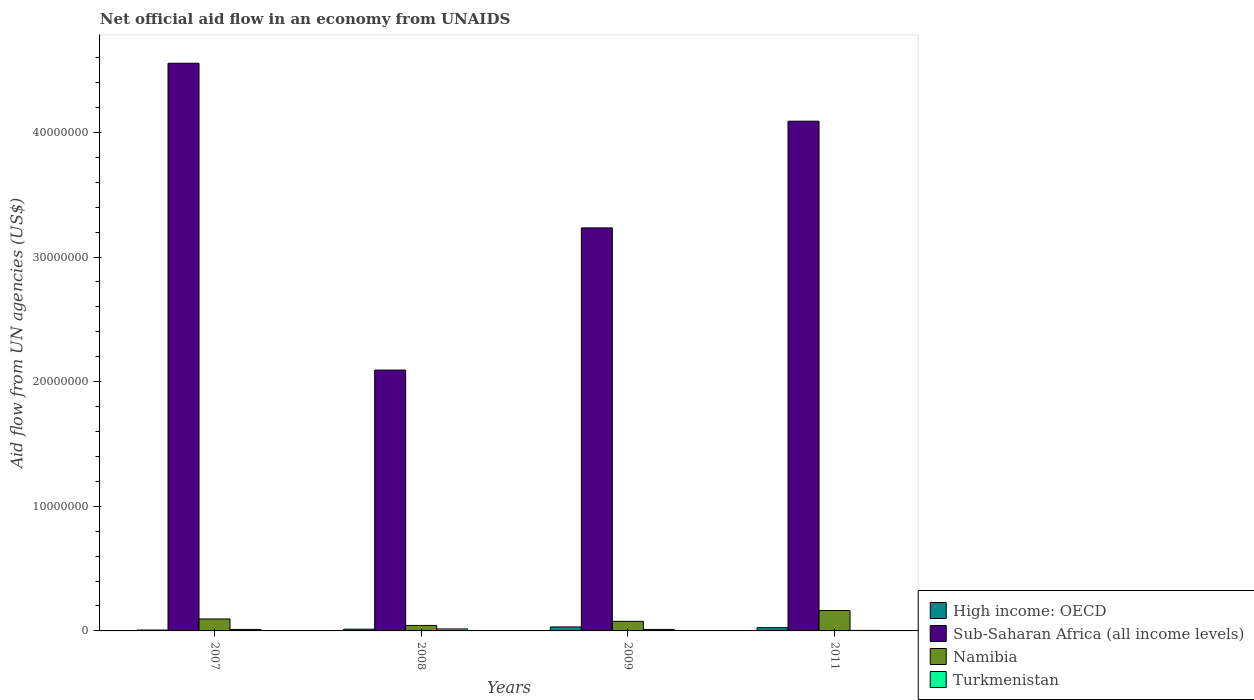How many bars are there on the 1st tick from the left?
Ensure brevity in your answer.  4. What is the label of the 4th group of bars from the left?
Offer a terse response. 2011. In how many cases, is the number of bars for a given year not equal to the number of legend labels?
Provide a short and direct response. 0. What is the net official aid flow in High income: OECD in 2011?
Your answer should be very brief. 2.60e+05. Across all years, what is the minimum net official aid flow in High income: OECD?
Provide a succinct answer. 7.00e+04. What is the total net official aid flow in High income: OECD in the graph?
Your answer should be compact. 7.90e+05. What is the difference between the net official aid flow in High income: OECD in 2007 and that in 2008?
Offer a terse response. -7.00e+04. What is the difference between the net official aid flow in Turkmenistan in 2011 and the net official aid flow in Namibia in 2007?
Your answer should be compact. -9.20e+05. What is the average net official aid flow in Sub-Saharan Africa (all income levels) per year?
Your answer should be very brief. 3.49e+07. In how many years, is the net official aid flow in Sub-Saharan Africa (all income levels) greater than 14000000 US$?
Provide a succinct answer. 4. What is the ratio of the net official aid flow in Sub-Saharan Africa (all income levels) in 2008 to that in 2011?
Offer a terse response. 0.51. Is the net official aid flow in Sub-Saharan Africa (all income levels) in 2007 less than that in 2008?
Keep it short and to the point. No. What is the difference between the highest and the second highest net official aid flow in Namibia?
Give a very brief answer. 6.80e+05. What is the difference between the highest and the lowest net official aid flow in High income: OECD?
Give a very brief answer. 2.50e+05. Is the sum of the net official aid flow in Sub-Saharan Africa (all income levels) in 2007 and 2009 greater than the maximum net official aid flow in High income: OECD across all years?
Provide a short and direct response. Yes. Is it the case that in every year, the sum of the net official aid flow in Namibia and net official aid flow in Turkmenistan is greater than the sum of net official aid flow in Sub-Saharan Africa (all income levels) and net official aid flow in High income: OECD?
Keep it short and to the point. Yes. What does the 4th bar from the left in 2009 represents?
Keep it short and to the point. Turkmenistan. What does the 3rd bar from the right in 2011 represents?
Give a very brief answer. Sub-Saharan Africa (all income levels). Is it the case that in every year, the sum of the net official aid flow in Turkmenistan and net official aid flow in High income: OECD is greater than the net official aid flow in Sub-Saharan Africa (all income levels)?
Offer a terse response. No. How many bars are there?
Your response must be concise. 16. Are all the bars in the graph horizontal?
Provide a short and direct response. No. Are the values on the major ticks of Y-axis written in scientific E-notation?
Your response must be concise. No. Does the graph contain any zero values?
Keep it short and to the point. No. Does the graph contain grids?
Ensure brevity in your answer.  No. Where does the legend appear in the graph?
Provide a short and direct response. Bottom right. How many legend labels are there?
Your answer should be very brief. 4. What is the title of the graph?
Offer a terse response. Net official aid flow in an economy from UNAIDS. What is the label or title of the Y-axis?
Provide a succinct answer. Aid flow from UN agencies (US$). What is the Aid flow from UN agencies (US$) of Sub-Saharan Africa (all income levels) in 2007?
Your answer should be compact. 4.56e+07. What is the Aid flow from UN agencies (US$) in Namibia in 2007?
Your response must be concise. 9.60e+05. What is the Aid flow from UN agencies (US$) of Sub-Saharan Africa (all income levels) in 2008?
Your answer should be compact. 2.09e+07. What is the Aid flow from UN agencies (US$) in Namibia in 2008?
Offer a very short reply. 4.40e+05. What is the Aid flow from UN agencies (US$) of High income: OECD in 2009?
Your response must be concise. 3.20e+05. What is the Aid flow from UN agencies (US$) in Sub-Saharan Africa (all income levels) in 2009?
Give a very brief answer. 3.23e+07. What is the Aid flow from UN agencies (US$) in Namibia in 2009?
Offer a very short reply. 7.70e+05. What is the Aid flow from UN agencies (US$) of High income: OECD in 2011?
Provide a short and direct response. 2.60e+05. What is the Aid flow from UN agencies (US$) of Sub-Saharan Africa (all income levels) in 2011?
Give a very brief answer. 4.09e+07. What is the Aid flow from UN agencies (US$) in Namibia in 2011?
Keep it short and to the point. 1.64e+06. Across all years, what is the maximum Aid flow from UN agencies (US$) of Sub-Saharan Africa (all income levels)?
Give a very brief answer. 4.56e+07. Across all years, what is the maximum Aid flow from UN agencies (US$) in Namibia?
Provide a short and direct response. 1.64e+06. Across all years, what is the maximum Aid flow from UN agencies (US$) of Turkmenistan?
Give a very brief answer. 1.60e+05. Across all years, what is the minimum Aid flow from UN agencies (US$) in High income: OECD?
Provide a short and direct response. 7.00e+04. Across all years, what is the minimum Aid flow from UN agencies (US$) in Sub-Saharan Africa (all income levels)?
Your response must be concise. 2.09e+07. Across all years, what is the minimum Aid flow from UN agencies (US$) in Turkmenistan?
Provide a short and direct response. 4.00e+04. What is the total Aid flow from UN agencies (US$) of High income: OECD in the graph?
Offer a very short reply. 7.90e+05. What is the total Aid flow from UN agencies (US$) of Sub-Saharan Africa (all income levels) in the graph?
Keep it short and to the point. 1.40e+08. What is the total Aid flow from UN agencies (US$) in Namibia in the graph?
Give a very brief answer. 3.81e+06. What is the difference between the Aid flow from UN agencies (US$) of Sub-Saharan Africa (all income levels) in 2007 and that in 2008?
Make the answer very short. 2.46e+07. What is the difference between the Aid flow from UN agencies (US$) of Namibia in 2007 and that in 2008?
Your response must be concise. 5.20e+05. What is the difference between the Aid flow from UN agencies (US$) of Sub-Saharan Africa (all income levels) in 2007 and that in 2009?
Your answer should be very brief. 1.32e+07. What is the difference between the Aid flow from UN agencies (US$) of High income: OECD in 2007 and that in 2011?
Give a very brief answer. -1.90e+05. What is the difference between the Aid flow from UN agencies (US$) in Sub-Saharan Africa (all income levels) in 2007 and that in 2011?
Provide a succinct answer. 4.65e+06. What is the difference between the Aid flow from UN agencies (US$) in Namibia in 2007 and that in 2011?
Give a very brief answer. -6.80e+05. What is the difference between the Aid flow from UN agencies (US$) in Turkmenistan in 2007 and that in 2011?
Give a very brief answer. 8.00e+04. What is the difference between the Aid flow from UN agencies (US$) in High income: OECD in 2008 and that in 2009?
Provide a short and direct response. -1.80e+05. What is the difference between the Aid flow from UN agencies (US$) in Sub-Saharan Africa (all income levels) in 2008 and that in 2009?
Make the answer very short. -1.14e+07. What is the difference between the Aid flow from UN agencies (US$) in Namibia in 2008 and that in 2009?
Your answer should be compact. -3.30e+05. What is the difference between the Aid flow from UN agencies (US$) in Sub-Saharan Africa (all income levels) in 2008 and that in 2011?
Offer a terse response. -2.00e+07. What is the difference between the Aid flow from UN agencies (US$) of Namibia in 2008 and that in 2011?
Keep it short and to the point. -1.20e+06. What is the difference between the Aid flow from UN agencies (US$) of High income: OECD in 2009 and that in 2011?
Your answer should be compact. 6.00e+04. What is the difference between the Aid flow from UN agencies (US$) of Sub-Saharan Africa (all income levels) in 2009 and that in 2011?
Make the answer very short. -8.56e+06. What is the difference between the Aid flow from UN agencies (US$) of Namibia in 2009 and that in 2011?
Your answer should be compact. -8.70e+05. What is the difference between the Aid flow from UN agencies (US$) of High income: OECD in 2007 and the Aid flow from UN agencies (US$) of Sub-Saharan Africa (all income levels) in 2008?
Provide a succinct answer. -2.09e+07. What is the difference between the Aid flow from UN agencies (US$) in High income: OECD in 2007 and the Aid flow from UN agencies (US$) in Namibia in 2008?
Offer a very short reply. -3.70e+05. What is the difference between the Aid flow from UN agencies (US$) of Sub-Saharan Africa (all income levels) in 2007 and the Aid flow from UN agencies (US$) of Namibia in 2008?
Ensure brevity in your answer.  4.51e+07. What is the difference between the Aid flow from UN agencies (US$) in Sub-Saharan Africa (all income levels) in 2007 and the Aid flow from UN agencies (US$) in Turkmenistan in 2008?
Offer a very short reply. 4.54e+07. What is the difference between the Aid flow from UN agencies (US$) of Namibia in 2007 and the Aid flow from UN agencies (US$) of Turkmenistan in 2008?
Your answer should be compact. 8.00e+05. What is the difference between the Aid flow from UN agencies (US$) in High income: OECD in 2007 and the Aid flow from UN agencies (US$) in Sub-Saharan Africa (all income levels) in 2009?
Offer a terse response. -3.23e+07. What is the difference between the Aid flow from UN agencies (US$) of High income: OECD in 2007 and the Aid flow from UN agencies (US$) of Namibia in 2009?
Provide a succinct answer. -7.00e+05. What is the difference between the Aid flow from UN agencies (US$) of High income: OECD in 2007 and the Aid flow from UN agencies (US$) of Turkmenistan in 2009?
Your response must be concise. -5.00e+04. What is the difference between the Aid flow from UN agencies (US$) of Sub-Saharan Africa (all income levels) in 2007 and the Aid flow from UN agencies (US$) of Namibia in 2009?
Your answer should be compact. 4.48e+07. What is the difference between the Aid flow from UN agencies (US$) in Sub-Saharan Africa (all income levels) in 2007 and the Aid flow from UN agencies (US$) in Turkmenistan in 2009?
Offer a very short reply. 4.54e+07. What is the difference between the Aid flow from UN agencies (US$) of Namibia in 2007 and the Aid flow from UN agencies (US$) of Turkmenistan in 2009?
Keep it short and to the point. 8.40e+05. What is the difference between the Aid flow from UN agencies (US$) of High income: OECD in 2007 and the Aid flow from UN agencies (US$) of Sub-Saharan Africa (all income levels) in 2011?
Keep it short and to the point. -4.08e+07. What is the difference between the Aid flow from UN agencies (US$) of High income: OECD in 2007 and the Aid flow from UN agencies (US$) of Namibia in 2011?
Ensure brevity in your answer.  -1.57e+06. What is the difference between the Aid flow from UN agencies (US$) of High income: OECD in 2007 and the Aid flow from UN agencies (US$) of Turkmenistan in 2011?
Offer a terse response. 3.00e+04. What is the difference between the Aid flow from UN agencies (US$) of Sub-Saharan Africa (all income levels) in 2007 and the Aid flow from UN agencies (US$) of Namibia in 2011?
Provide a succinct answer. 4.39e+07. What is the difference between the Aid flow from UN agencies (US$) in Sub-Saharan Africa (all income levels) in 2007 and the Aid flow from UN agencies (US$) in Turkmenistan in 2011?
Give a very brief answer. 4.55e+07. What is the difference between the Aid flow from UN agencies (US$) in Namibia in 2007 and the Aid flow from UN agencies (US$) in Turkmenistan in 2011?
Provide a succinct answer. 9.20e+05. What is the difference between the Aid flow from UN agencies (US$) of High income: OECD in 2008 and the Aid flow from UN agencies (US$) of Sub-Saharan Africa (all income levels) in 2009?
Offer a terse response. -3.22e+07. What is the difference between the Aid flow from UN agencies (US$) of High income: OECD in 2008 and the Aid flow from UN agencies (US$) of Namibia in 2009?
Your response must be concise. -6.30e+05. What is the difference between the Aid flow from UN agencies (US$) of High income: OECD in 2008 and the Aid flow from UN agencies (US$) of Turkmenistan in 2009?
Provide a succinct answer. 2.00e+04. What is the difference between the Aid flow from UN agencies (US$) in Sub-Saharan Africa (all income levels) in 2008 and the Aid flow from UN agencies (US$) in Namibia in 2009?
Ensure brevity in your answer.  2.02e+07. What is the difference between the Aid flow from UN agencies (US$) of Sub-Saharan Africa (all income levels) in 2008 and the Aid flow from UN agencies (US$) of Turkmenistan in 2009?
Provide a short and direct response. 2.08e+07. What is the difference between the Aid flow from UN agencies (US$) of Namibia in 2008 and the Aid flow from UN agencies (US$) of Turkmenistan in 2009?
Give a very brief answer. 3.20e+05. What is the difference between the Aid flow from UN agencies (US$) of High income: OECD in 2008 and the Aid flow from UN agencies (US$) of Sub-Saharan Africa (all income levels) in 2011?
Keep it short and to the point. -4.08e+07. What is the difference between the Aid flow from UN agencies (US$) of High income: OECD in 2008 and the Aid flow from UN agencies (US$) of Namibia in 2011?
Provide a succinct answer. -1.50e+06. What is the difference between the Aid flow from UN agencies (US$) of Sub-Saharan Africa (all income levels) in 2008 and the Aid flow from UN agencies (US$) of Namibia in 2011?
Your answer should be compact. 1.93e+07. What is the difference between the Aid flow from UN agencies (US$) of Sub-Saharan Africa (all income levels) in 2008 and the Aid flow from UN agencies (US$) of Turkmenistan in 2011?
Provide a succinct answer. 2.09e+07. What is the difference between the Aid flow from UN agencies (US$) of Namibia in 2008 and the Aid flow from UN agencies (US$) of Turkmenistan in 2011?
Offer a very short reply. 4.00e+05. What is the difference between the Aid flow from UN agencies (US$) of High income: OECD in 2009 and the Aid flow from UN agencies (US$) of Sub-Saharan Africa (all income levels) in 2011?
Offer a terse response. -4.06e+07. What is the difference between the Aid flow from UN agencies (US$) in High income: OECD in 2009 and the Aid flow from UN agencies (US$) in Namibia in 2011?
Your answer should be very brief. -1.32e+06. What is the difference between the Aid flow from UN agencies (US$) of High income: OECD in 2009 and the Aid flow from UN agencies (US$) of Turkmenistan in 2011?
Your response must be concise. 2.80e+05. What is the difference between the Aid flow from UN agencies (US$) in Sub-Saharan Africa (all income levels) in 2009 and the Aid flow from UN agencies (US$) in Namibia in 2011?
Ensure brevity in your answer.  3.07e+07. What is the difference between the Aid flow from UN agencies (US$) of Sub-Saharan Africa (all income levels) in 2009 and the Aid flow from UN agencies (US$) of Turkmenistan in 2011?
Ensure brevity in your answer.  3.23e+07. What is the difference between the Aid flow from UN agencies (US$) of Namibia in 2009 and the Aid flow from UN agencies (US$) of Turkmenistan in 2011?
Give a very brief answer. 7.30e+05. What is the average Aid flow from UN agencies (US$) in High income: OECD per year?
Ensure brevity in your answer.  1.98e+05. What is the average Aid flow from UN agencies (US$) of Sub-Saharan Africa (all income levels) per year?
Your response must be concise. 3.49e+07. What is the average Aid flow from UN agencies (US$) in Namibia per year?
Your response must be concise. 9.52e+05. What is the average Aid flow from UN agencies (US$) in Turkmenistan per year?
Ensure brevity in your answer.  1.10e+05. In the year 2007, what is the difference between the Aid flow from UN agencies (US$) of High income: OECD and Aid flow from UN agencies (US$) of Sub-Saharan Africa (all income levels)?
Ensure brevity in your answer.  -4.55e+07. In the year 2007, what is the difference between the Aid flow from UN agencies (US$) in High income: OECD and Aid flow from UN agencies (US$) in Namibia?
Offer a terse response. -8.90e+05. In the year 2007, what is the difference between the Aid flow from UN agencies (US$) of High income: OECD and Aid flow from UN agencies (US$) of Turkmenistan?
Make the answer very short. -5.00e+04. In the year 2007, what is the difference between the Aid flow from UN agencies (US$) in Sub-Saharan Africa (all income levels) and Aid flow from UN agencies (US$) in Namibia?
Provide a short and direct response. 4.46e+07. In the year 2007, what is the difference between the Aid flow from UN agencies (US$) of Sub-Saharan Africa (all income levels) and Aid flow from UN agencies (US$) of Turkmenistan?
Ensure brevity in your answer.  4.54e+07. In the year 2007, what is the difference between the Aid flow from UN agencies (US$) in Namibia and Aid flow from UN agencies (US$) in Turkmenistan?
Your answer should be compact. 8.40e+05. In the year 2008, what is the difference between the Aid flow from UN agencies (US$) of High income: OECD and Aid flow from UN agencies (US$) of Sub-Saharan Africa (all income levels)?
Provide a short and direct response. -2.08e+07. In the year 2008, what is the difference between the Aid flow from UN agencies (US$) in High income: OECD and Aid flow from UN agencies (US$) in Turkmenistan?
Your response must be concise. -2.00e+04. In the year 2008, what is the difference between the Aid flow from UN agencies (US$) of Sub-Saharan Africa (all income levels) and Aid flow from UN agencies (US$) of Namibia?
Offer a very short reply. 2.05e+07. In the year 2008, what is the difference between the Aid flow from UN agencies (US$) of Sub-Saharan Africa (all income levels) and Aid flow from UN agencies (US$) of Turkmenistan?
Your answer should be compact. 2.08e+07. In the year 2008, what is the difference between the Aid flow from UN agencies (US$) of Namibia and Aid flow from UN agencies (US$) of Turkmenistan?
Your response must be concise. 2.80e+05. In the year 2009, what is the difference between the Aid flow from UN agencies (US$) in High income: OECD and Aid flow from UN agencies (US$) in Sub-Saharan Africa (all income levels)?
Ensure brevity in your answer.  -3.20e+07. In the year 2009, what is the difference between the Aid flow from UN agencies (US$) in High income: OECD and Aid flow from UN agencies (US$) in Namibia?
Make the answer very short. -4.50e+05. In the year 2009, what is the difference between the Aid flow from UN agencies (US$) in High income: OECD and Aid flow from UN agencies (US$) in Turkmenistan?
Your answer should be compact. 2.00e+05. In the year 2009, what is the difference between the Aid flow from UN agencies (US$) in Sub-Saharan Africa (all income levels) and Aid flow from UN agencies (US$) in Namibia?
Provide a succinct answer. 3.16e+07. In the year 2009, what is the difference between the Aid flow from UN agencies (US$) in Sub-Saharan Africa (all income levels) and Aid flow from UN agencies (US$) in Turkmenistan?
Provide a succinct answer. 3.22e+07. In the year 2009, what is the difference between the Aid flow from UN agencies (US$) in Namibia and Aid flow from UN agencies (US$) in Turkmenistan?
Keep it short and to the point. 6.50e+05. In the year 2011, what is the difference between the Aid flow from UN agencies (US$) of High income: OECD and Aid flow from UN agencies (US$) of Sub-Saharan Africa (all income levels)?
Offer a very short reply. -4.06e+07. In the year 2011, what is the difference between the Aid flow from UN agencies (US$) in High income: OECD and Aid flow from UN agencies (US$) in Namibia?
Provide a short and direct response. -1.38e+06. In the year 2011, what is the difference between the Aid flow from UN agencies (US$) in Sub-Saharan Africa (all income levels) and Aid flow from UN agencies (US$) in Namibia?
Your answer should be very brief. 3.93e+07. In the year 2011, what is the difference between the Aid flow from UN agencies (US$) in Sub-Saharan Africa (all income levels) and Aid flow from UN agencies (US$) in Turkmenistan?
Give a very brief answer. 4.09e+07. In the year 2011, what is the difference between the Aid flow from UN agencies (US$) of Namibia and Aid flow from UN agencies (US$) of Turkmenistan?
Your answer should be compact. 1.60e+06. What is the ratio of the Aid flow from UN agencies (US$) in High income: OECD in 2007 to that in 2008?
Make the answer very short. 0.5. What is the ratio of the Aid flow from UN agencies (US$) in Sub-Saharan Africa (all income levels) in 2007 to that in 2008?
Keep it short and to the point. 2.18. What is the ratio of the Aid flow from UN agencies (US$) in Namibia in 2007 to that in 2008?
Keep it short and to the point. 2.18. What is the ratio of the Aid flow from UN agencies (US$) in High income: OECD in 2007 to that in 2009?
Offer a very short reply. 0.22. What is the ratio of the Aid flow from UN agencies (US$) of Sub-Saharan Africa (all income levels) in 2007 to that in 2009?
Your response must be concise. 1.41. What is the ratio of the Aid flow from UN agencies (US$) of Namibia in 2007 to that in 2009?
Provide a succinct answer. 1.25. What is the ratio of the Aid flow from UN agencies (US$) of High income: OECD in 2007 to that in 2011?
Make the answer very short. 0.27. What is the ratio of the Aid flow from UN agencies (US$) in Sub-Saharan Africa (all income levels) in 2007 to that in 2011?
Provide a short and direct response. 1.11. What is the ratio of the Aid flow from UN agencies (US$) in Namibia in 2007 to that in 2011?
Offer a very short reply. 0.59. What is the ratio of the Aid flow from UN agencies (US$) in High income: OECD in 2008 to that in 2009?
Make the answer very short. 0.44. What is the ratio of the Aid flow from UN agencies (US$) of Sub-Saharan Africa (all income levels) in 2008 to that in 2009?
Give a very brief answer. 0.65. What is the ratio of the Aid flow from UN agencies (US$) in Namibia in 2008 to that in 2009?
Your answer should be very brief. 0.57. What is the ratio of the Aid flow from UN agencies (US$) in High income: OECD in 2008 to that in 2011?
Offer a very short reply. 0.54. What is the ratio of the Aid flow from UN agencies (US$) in Sub-Saharan Africa (all income levels) in 2008 to that in 2011?
Provide a short and direct response. 0.51. What is the ratio of the Aid flow from UN agencies (US$) of Namibia in 2008 to that in 2011?
Give a very brief answer. 0.27. What is the ratio of the Aid flow from UN agencies (US$) of High income: OECD in 2009 to that in 2011?
Your answer should be compact. 1.23. What is the ratio of the Aid flow from UN agencies (US$) in Sub-Saharan Africa (all income levels) in 2009 to that in 2011?
Keep it short and to the point. 0.79. What is the ratio of the Aid flow from UN agencies (US$) in Namibia in 2009 to that in 2011?
Offer a very short reply. 0.47. What is the ratio of the Aid flow from UN agencies (US$) of Turkmenistan in 2009 to that in 2011?
Provide a short and direct response. 3. What is the difference between the highest and the second highest Aid flow from UN agencies (US$) of High income: OECD?
Give a very brief answer. 6.00e+04. What is the difference between the highest and the second highest Aid flow from UN agencies (US$) of Sub-Saharan Africa (all income levels)?
Offer a very short reply. 4.65e+06. What is the difference between the highest and the second highest Aid flow from UN agencies (US$) in Namibia?
Your answer should be compact. 6.80e+05. What is the difference between the highest and the second highest Aid flow from UN agencies (US$) of Turkmenistan?
Provide a short and direct response. 4.00e+04. What is the difference between the highest and the lowest Aid flow from UN agencies (US$) in Sub-Saharan Africa (all income levels)?
Your response must be concise. 2.46e+07. What is the difference between the highest and the lowest Aid flow from UN agencies (US$) in Namibia?
Your answer should be very brief. 1.20e+06. What is the difference between the highest and the lowest Aid flow from UN agencies (US$) of Turkmenistan?
Ensure brevity in your answer.  1.20e+05. 